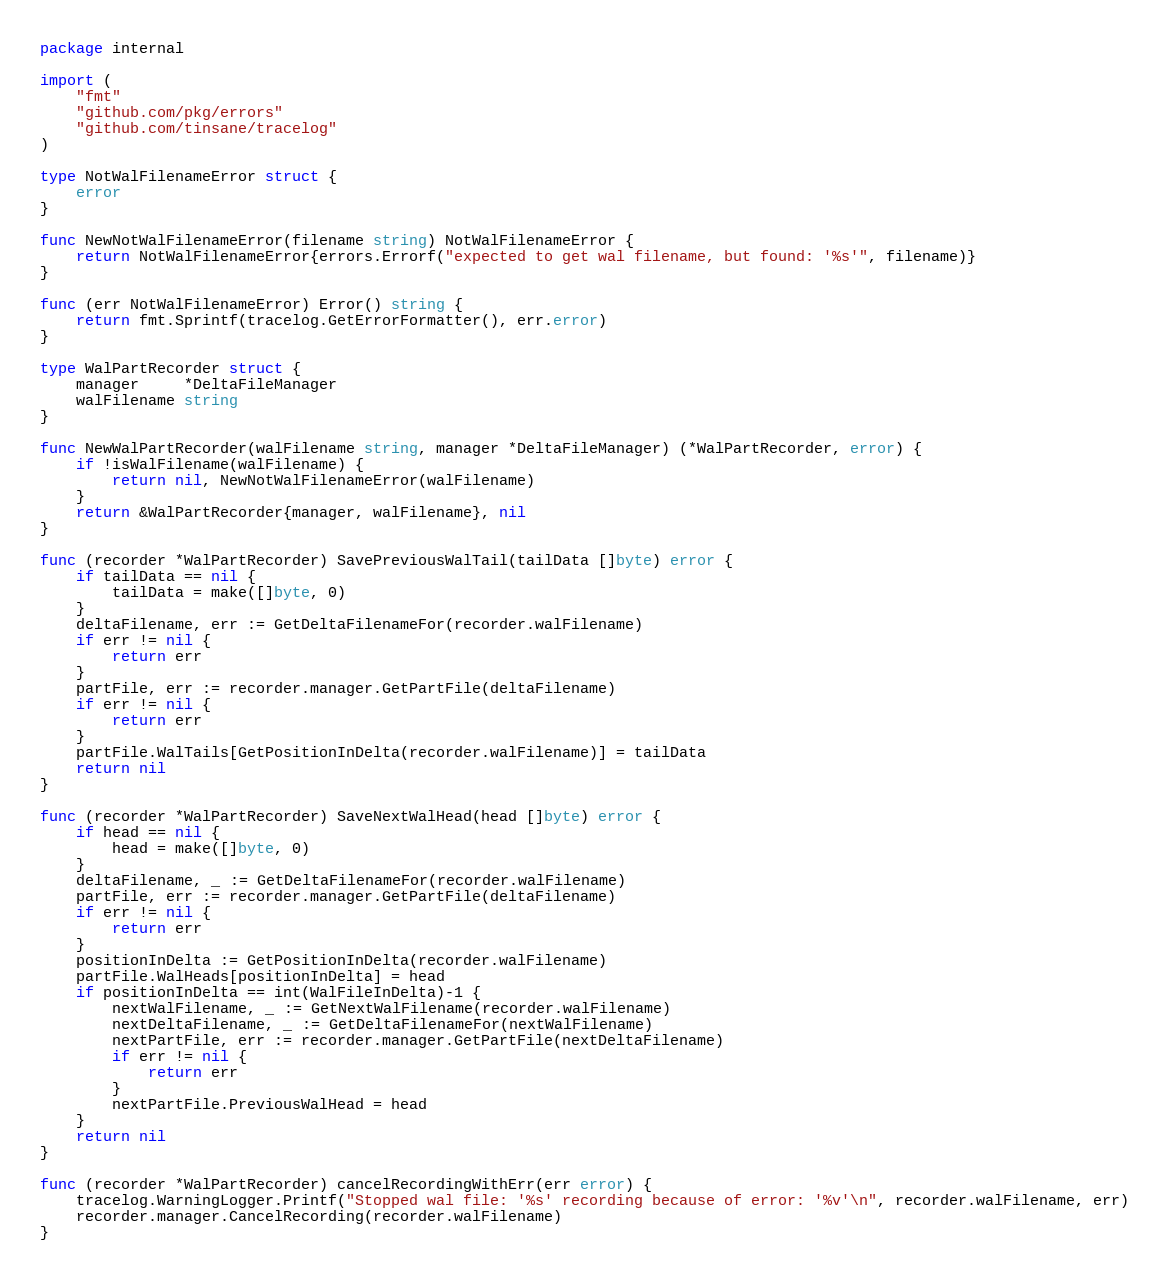Convert code to text. <code><loc_0><loc_0><loc_500><loc_500><_Go_>package internal

import (
	"fmt"
	"github.com/pkg/errors"
	"github.com/tinsane/tracelog"
)

type NotWalFilenameError struct {
	error
}

func NewNotWalFilenameError(filename string) NotWalFilenameError {
	return NotWalFilenameError{errors.Errorf("expected to get wal filename, but found: '%s'", filename)}
}

func (err NotWalFilenameError) Error() string {
	return fmt.Sprintf(tracelog.GetErrorFormatter(), err.error)
}

type WalPartRecorder struct {
	manager     *DeltaFileManager
	walFilename string
}

func NewWalPartRecorder(walFilename string, manager *DeltaFileManager) (*WalPartRecorder, error) {
	if !isWalFilename(walFilename) {
		return nil, NewNotWalFilenameError(walFilename)
	}
	return &WalPartRecorder{manager, walFilename}, nil
}

func (recorder *WalPartRecorder) SavePreviousWalTail(tailData []byte) error {
	if tailData == nil {
		tailData = make([]byte, 0)
	}
	deltaFilename, err := GetDeltaFilenameFor(recorder.walFilename)
	if err != nil {
		return err
	}
	partFile, err := recorder.manager.GetPartFile(deltaFilename)
	if err != nil {
		return err
	}
	partFile.WalTails[GetPositionInDelta(recorder.walFilename)] = tailData
	return nil
}

func (recorder *WalPartRecorder) SaveNextWalHead(head []byte) error {
	if head == nil {
		head = make([]byte, 0)
	}
	deltaFilename, _ := GetDeltaFilenameFor(recorder.walFilename)
	partFile, err := recorder.manager.GetPartFile(deltaFilename)
	if err != nil {
		return err
	}
	positionInDelta := GetPositionInDelta(recorder.walFilename)
	partFile.WalHeads[positionInDelta] = head
	if positionInDelta == int(WalFileInDelta)-1 {
		nextWalFilename, _ := GetNextWalFilename(recorder.walFilename)
		nextDeltaFilename, _ := GetDeltaFilenameFor(nextWalFilename)
		nextPartFile, err := recorder.manager.GetPartFile(nextDeltaFilename)
		if err != nil {
			return err
		}
		nextPartFile.PreviousWalHead = head
	}
	return nil
}

func (recorder *WalPartRecorder) cancelRecordingWithErr(err error) {
	tracelog.WarningLogger.Printf("Stopped wal file: '%s' recording because of error: '%v'\n", recorder.walFilename, err)
	recorder.manager.CancelRecording(recorder.walFilename)
}
</code> 